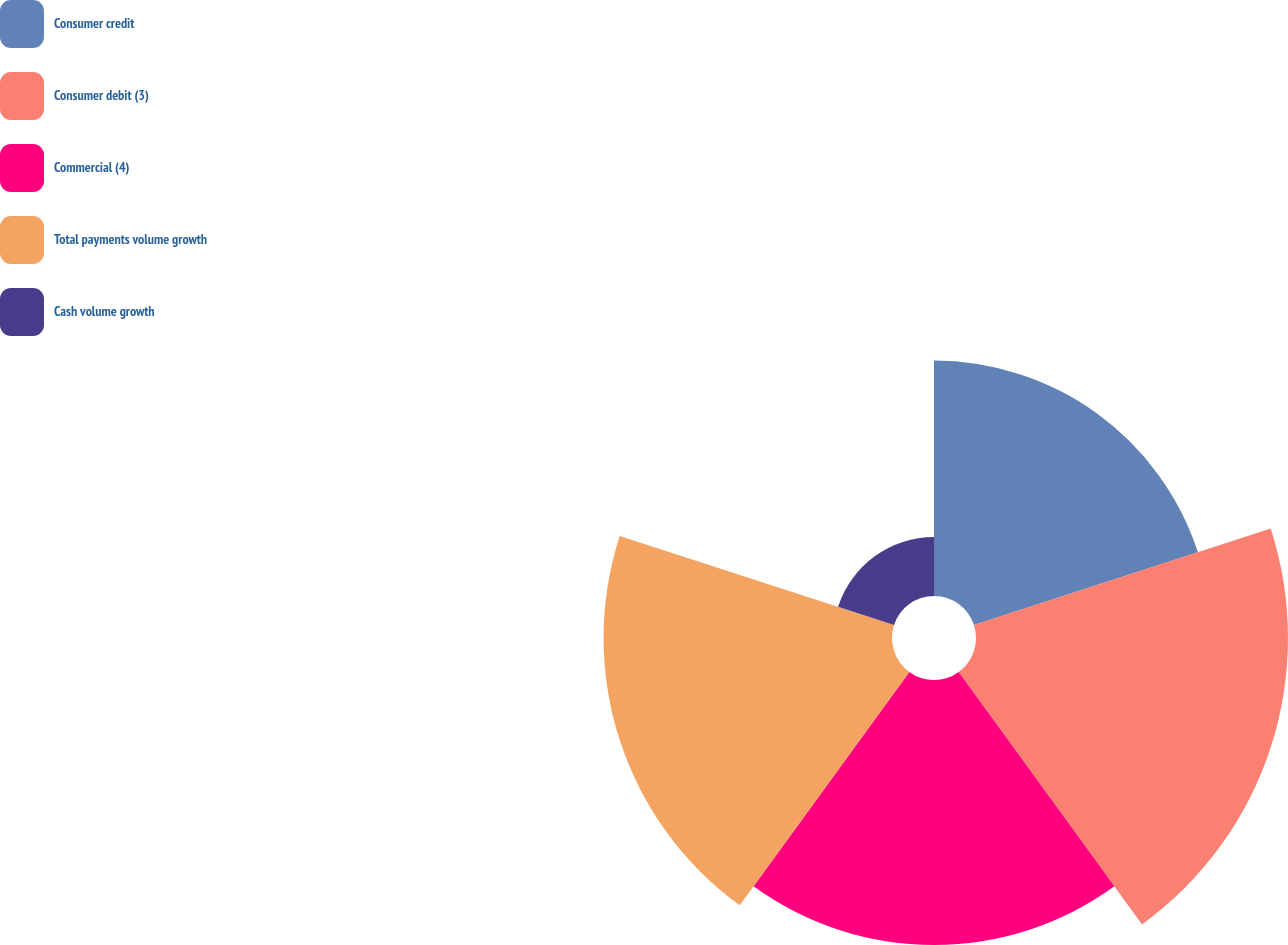<chart> <loc_0><loc_0><loc_500><loc_500><pie_chart><fcel>Consumer credit<fcel>Consumer debit (3)<fcel>Commercial (4)<fcel>Total payments volume growth<fcel>Cash volume growth<nl><fcel>20.3%<fcel>26.9%<fcel>22.84%<fcel>24.87%<fcel>5.08%<nl></chart> 